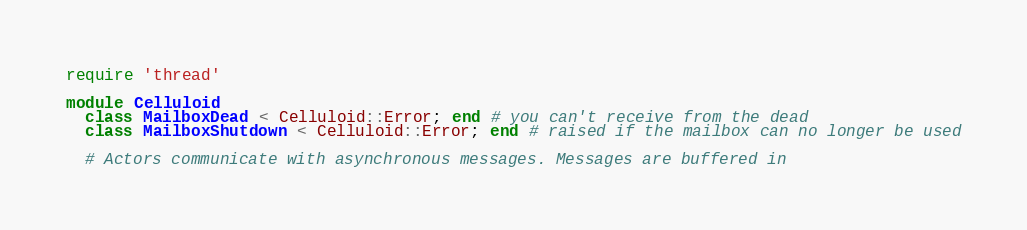Convert code to text. <code><loc_0><loc_0><loc_500><loc_500><_Ruby_>require 'thread'

module Celluloid
  class MailboxDead < Celluloid::Error; end # you can't receive from the dead
  class MailboxShutdown < Celluloid::Error; end # raised if the mailbox can no longer be used

  # Actors communicate with asynchronous messages. Messages are buffered in</code> 